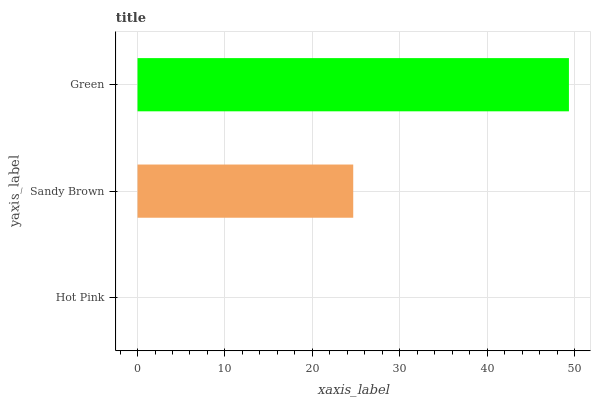Is Hot Pink the minimum?
Answer yes or no. Yes. Is Green the maximum?
Answer yes or no. Yes. Is Sandy Brown the minimum?
Answer yes or no. No. Is Sandy Brown the maximum?
Answer yes or no. No. Is Sandy Brown greater than Hot Pink?
Answer yes or no. Yes. Is Hot Pink less than Sandy Brown?
Answer yes or no. Yes. Is Hot Pink greater than Sandy Brown?
Answer yes or no. No. Is Sandy Brown less than Hot Pink?
Answer yes or no. No. Is Sandy Brown the high median?
Answer yes or no. Yes. Is Sandy Brown the low median?
Answer yes or no. Yes. Is Hot Pink the high median?
Answer yes or no. No. Is Hot Pink the low median?
Answer yes or no. No. 